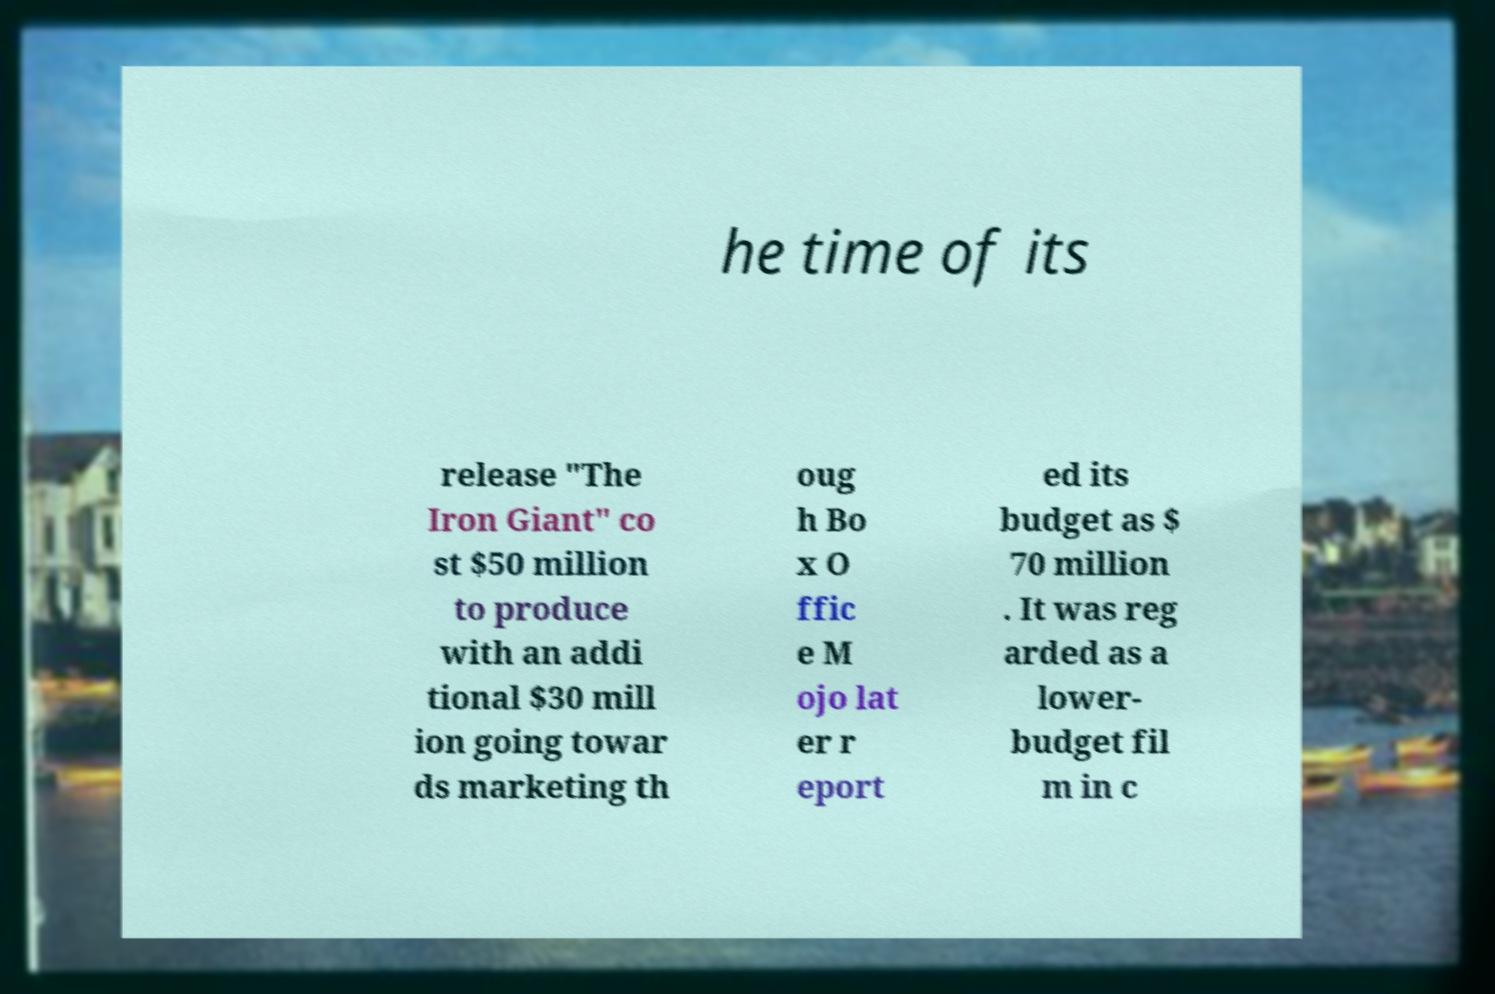Could you assist in decoding the text presented in this image and type it out clearly? he time of its release "The Iron Giant" co st $50 million to produce with an addi tional $30 mill ion going towar ds marketing th oug h Bo x O ffic e M ojo lat er r eport ed its budget as $ 70 million . It was reg arded as a lower- budget fil m in c 